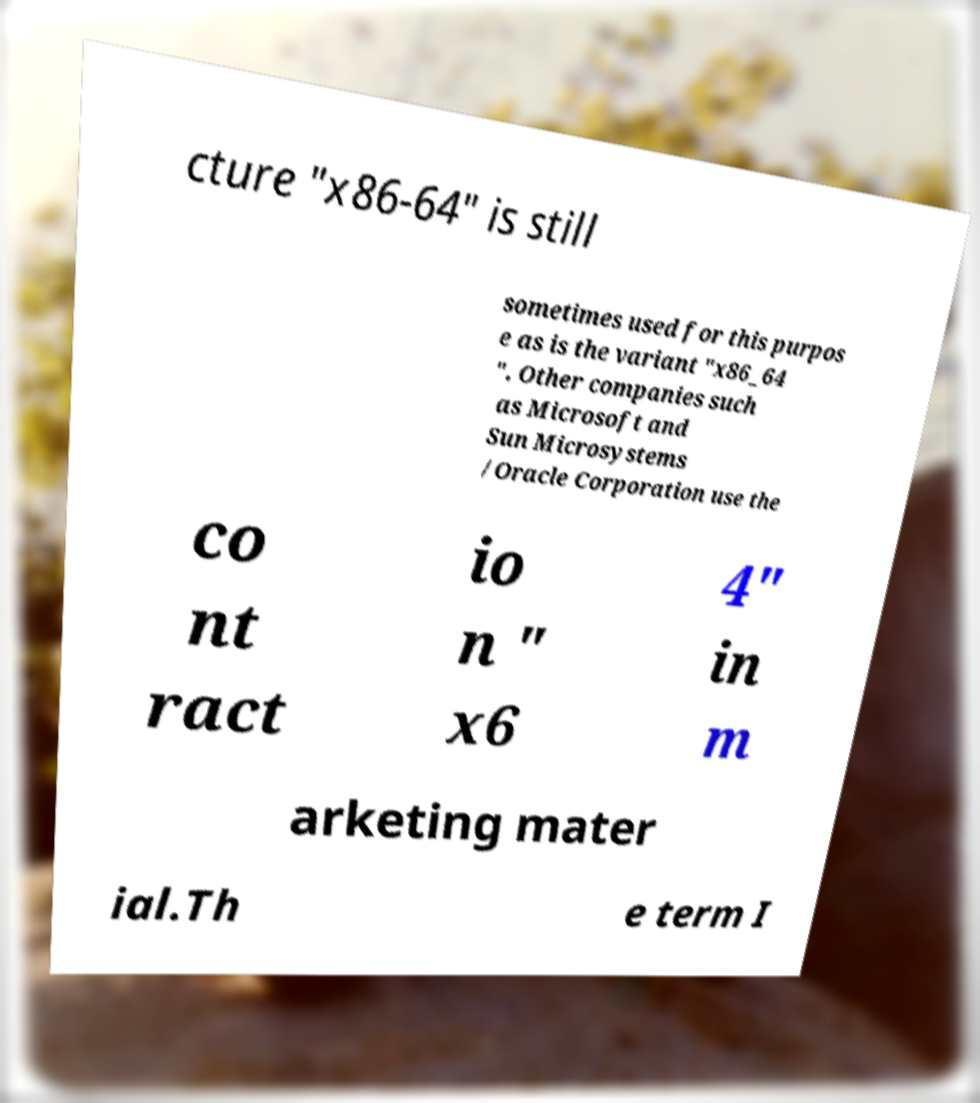What messages or text are displayed in this image? I need them in a readable, typed format. cture "x86-64" is still sometimes used for this purpos e as is the variant "x86_64 ". Other companies such as Microsoft and Sun Microsystems /Oracle Corporation use the co nt ract io n " x6 4" in m arketing mater ial.Th e term I 